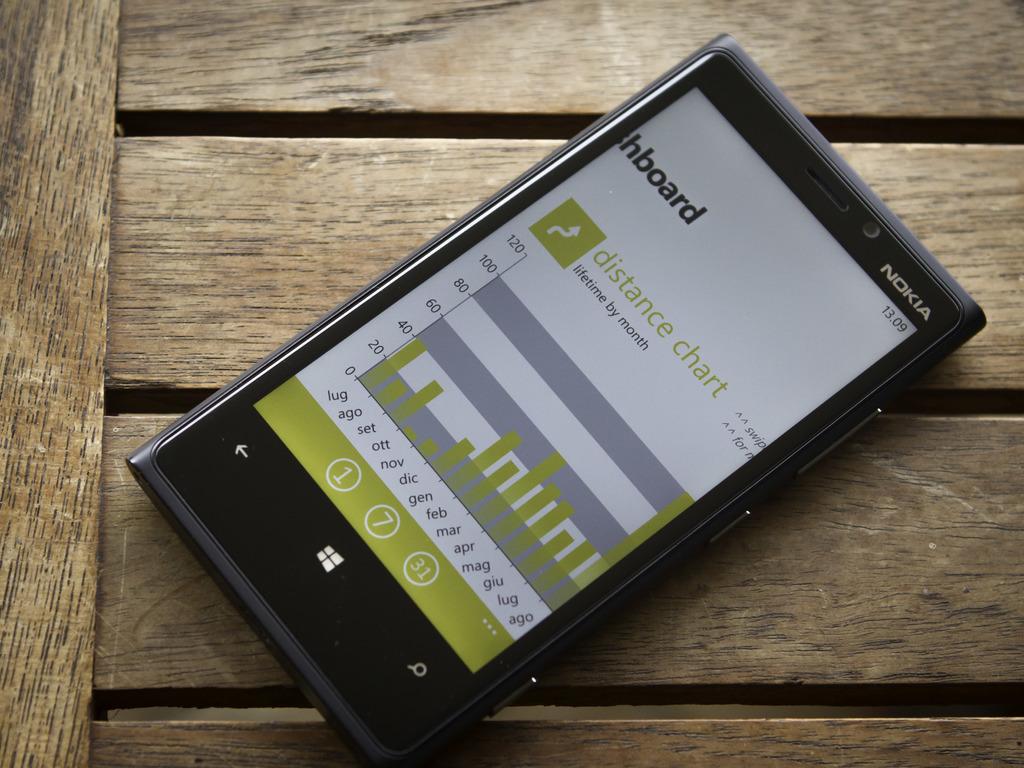What brand of phone is shown here?
Offer a very short reply. Nokia. 